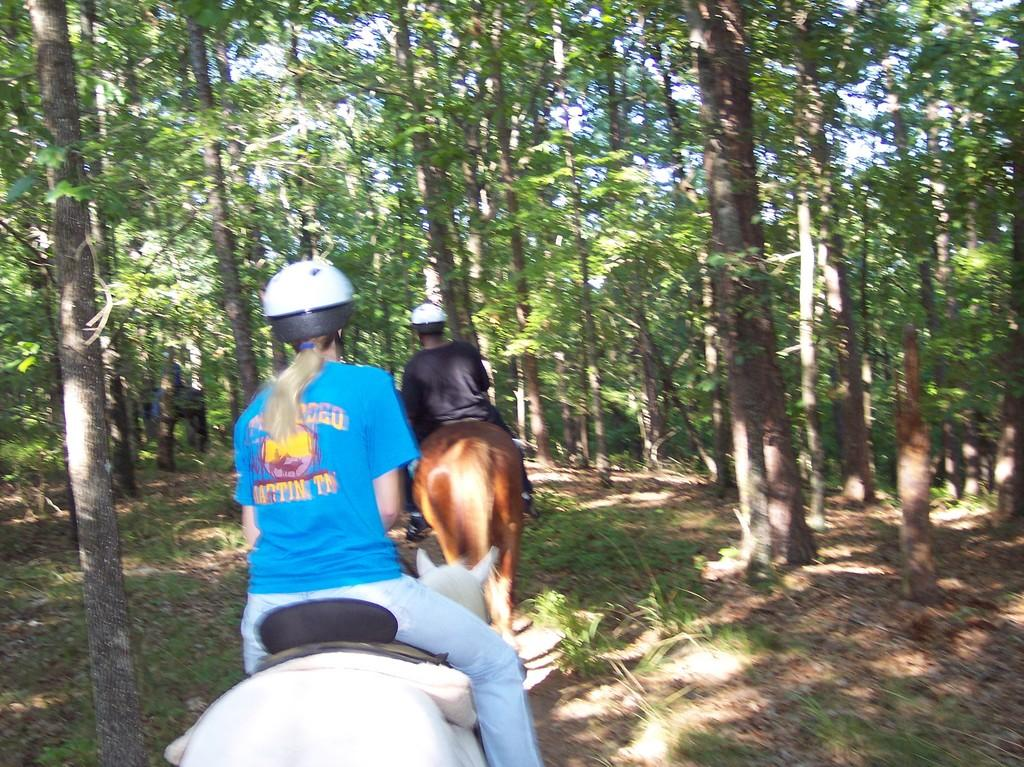What is the lady in the image wearing? The lady is wearing a blue t-shirt in the image. What are the men in the image wearing? The men are wearing black t-shirts in the image. What activity are the lady and men engaged in? The lady and men are riding on a horse in the image. What can be seen in the background of the image? There are many trees in the background of the image. What type of coil can be seen in the image? There is no coil present in the image. Is there a band performing in the image? There is no band or performance depicted in the image. 